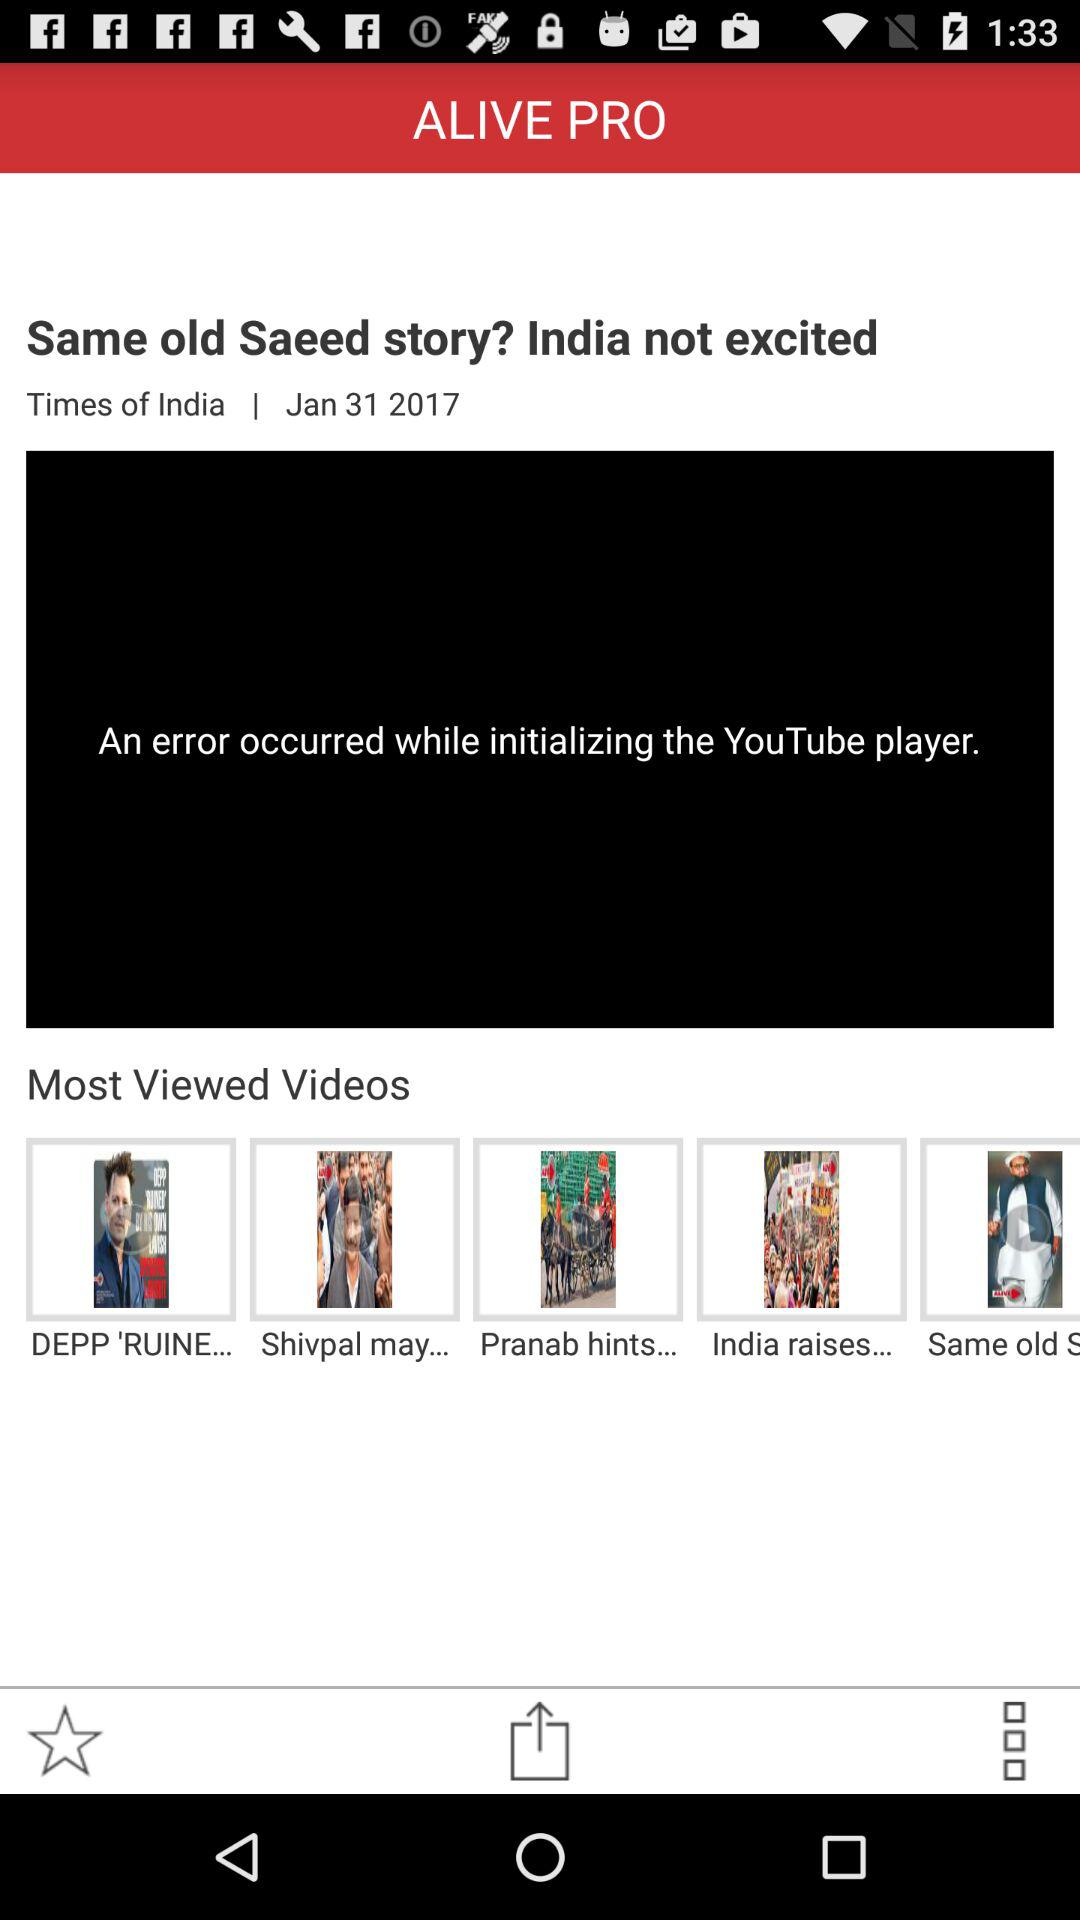What is the news channel name? The news channel name is "Times of India". 